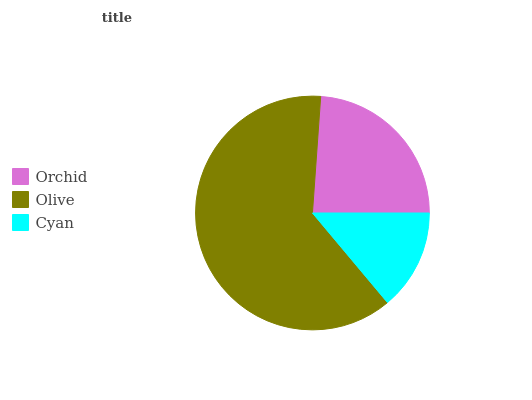Is Cyan the minimum?
Answer yes or no. Yes. Is Olive the maximum?
Answer yes or no. Yes. Is Olive the minimum?
Answer yes or no. No. Is Cyan the maximum?
Answer yes or no. No. Is Olive greater than Cyan?
Answer yes or no. Yes. Is Cyan less than Olive?
Answer yes or no. Yes. Is Cyan greater than Olive?
Answer yes or no. No. Is Olive less than Cyan?
Answer yes or no. No. Is Orchid the high median?
Answer yes or no. Yes. Is Orchid the low median?
Answer yes or no. Yes. Is Olive the high median?
Answer yes or no. No. Is Cyan the low median?
Answer yes or no. No. 